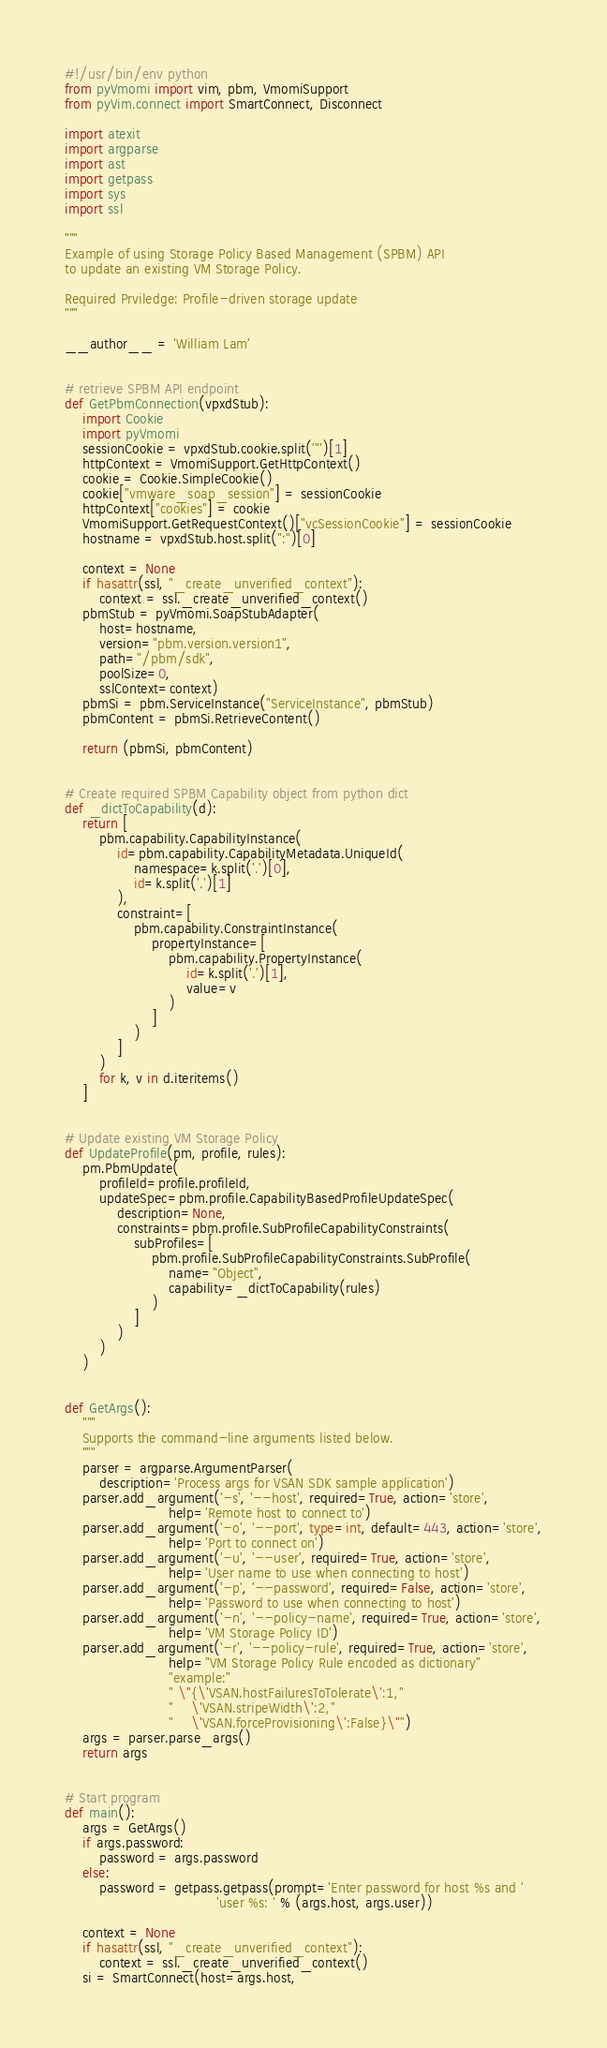Convert code to text. <code><loc_0><loc_0><loc_500><loc_500><_Python_>#!/usr/bin/env python
from pyVmomi import vim, pbm, VmomiSupport
from pyVim.connect import SmartConnect, Disconnect

import atexit
import argparse
import ast
import getpass
import sys
import ssl

"""
Example of using Storage Policy Based Management (SPBM) API
to update an existing VM Storage Policy.

Required Prviledge: Profile-driven storage update
"""

__author__ = 'William Lam'


# retrieve SPBM API endpoint
def GetPbmConnection(vpxdStub):
    import Cookie
    import pyVmomi
    sessionCookie = vpxdStub.cookie.split('"')[1]
    httpContext = VmomiSupport.GetHttpContext()
    cookie = Cookie.SimpleCookie()
    cookie["vmware_soap_session"] = sessionCookie
    httpContext["cookies"] = cookie
    VmomiSupport.GetRequestContext()["vcSessionCookie"] = sessionCookie
    hostname = vpxdStub.host.split(":")[0]

    context = None
    if hasattr(ssl, "_create_unverified_context"):
        context = ssl._create_unverified_context()
    pbmStub = pyVmomi.SoapStubAdapter(
        host=hostname,
        version="pbm.version.version1",
        path="/pbm/sdk",
        poolSize=0,
        sslContext=context)
    pbmSi = pbm.ServiceInstance("ServiceInstance", pbmStub)
    pbmContent = pbmSi.RetrieveContent()

    return (pbmSi, pbmContent)


# Create required SPBM Capability object from python dict
def _dictToCapability(d):
    return [
        pbm.capability.CapabilityInstance(
            id=pbm.capability.CapabilityMetadata.UniqueId(
                namespace=k.split('.')[0],
                id=k.split('.')[1]
            ),
            constraint=[
                pbm.capability.ConstraintInstance(
                    propertyInstance=[
                        pbm.capability.PropertyInstance(
                            id=k.split('.')[1],
                            value=v
                        )
                    ]
                )
            ]
        )
        for k, v in d.iteritems()
    ]


# Update existing VM Storage Policy
def UpdateProfile(pm, profile, rules):
    pm.PbmUpdate(
        profileId=profile.profileId,
        updateSpec=pbm.profile.CapabilityBasedProfileUpdateSpec(
            description=None,
            constraints=pbm.profile.SubProfileCapabilityConstraints(
                subProfiles=[
                    pbm.profile.SubProfileCapabilityConstraints.SubProfile(
                        name="Object",
                        capability=_dictToCapability(rules)
                    )
                ]
            )
        )
    )


def GetArgs():
    """
    Supports the command-line arguments listed below.
    """
    parser = argparse.ArgumentParser(
        description='Process args for VSAN SDK sample application')
    parser.add_argument('-s', '--host', required=True, action='store',
                        help='Remote host to connect to')
    parser.add_argument('-o', '--port', type=int, default=443, action='store',
                        help='Port to connect on')
    parser.add_argument('-u', '--user', required=True, action='store',
                        help='User name to use when connecting to host')
    parser.add_argument('-p', '--password', required=False, action='store',
                        help='Password to use when connecting to host')
    parser.add_argument('-n', '--policy-name', required=True, action='store',
                        help='VM Storage Policy ID')
    parser.add_argument('-r', '--policy-rule', required=True, action='store',
                        help="VM Storage Policy Rule encoded as dictionary"
                        "example:"
                        " \"{\'VSAN.hostFailuresToTolerate\':1,"
                        "    \'VSAN.stripeWidth\':2,"
                        "    \'VSAN.forceProvisioning\':False}\"")
    args = parser.parse_args()
    return args


# Start program
def main():
    args = GetArgs()
    if args.password:
        password = args.password
    else:
        password = getpass.getpass(prompt='Enter password for host %s and '
                                   'user %s: ' % (args.host, args.user))

    context = None
    if hasattr(ssl, "_create_unverified_context"):
        context = ssl._create_unverified_context()
    si = SmartConnect(host=args.host,</code> 